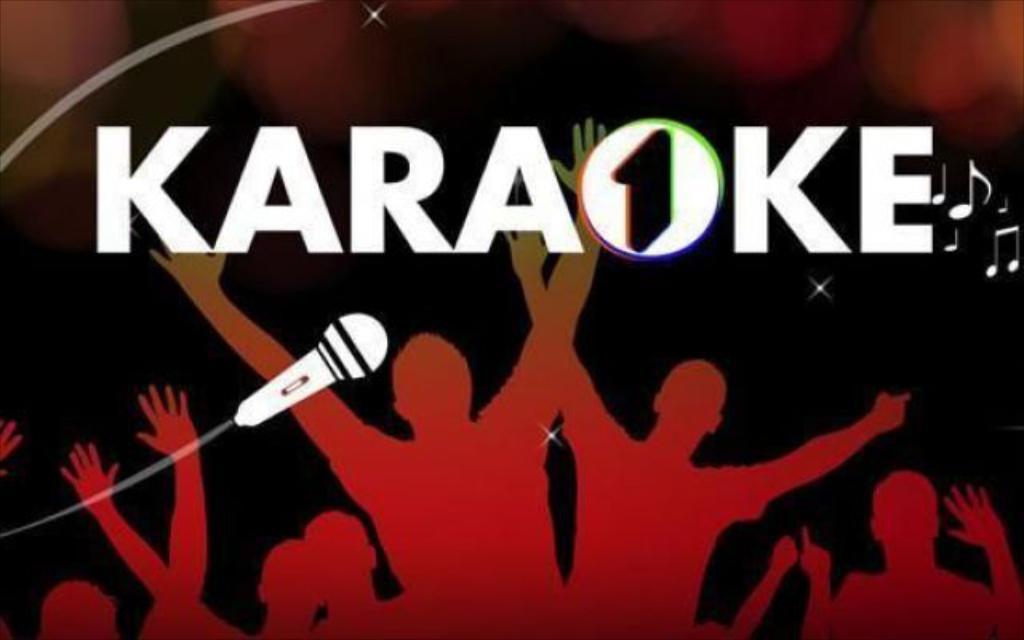What event is the sign advertising?
Keep it short and to the point. Karaoke. What musical instrument is on the sign?
Your answer should be compact. Microphone. 